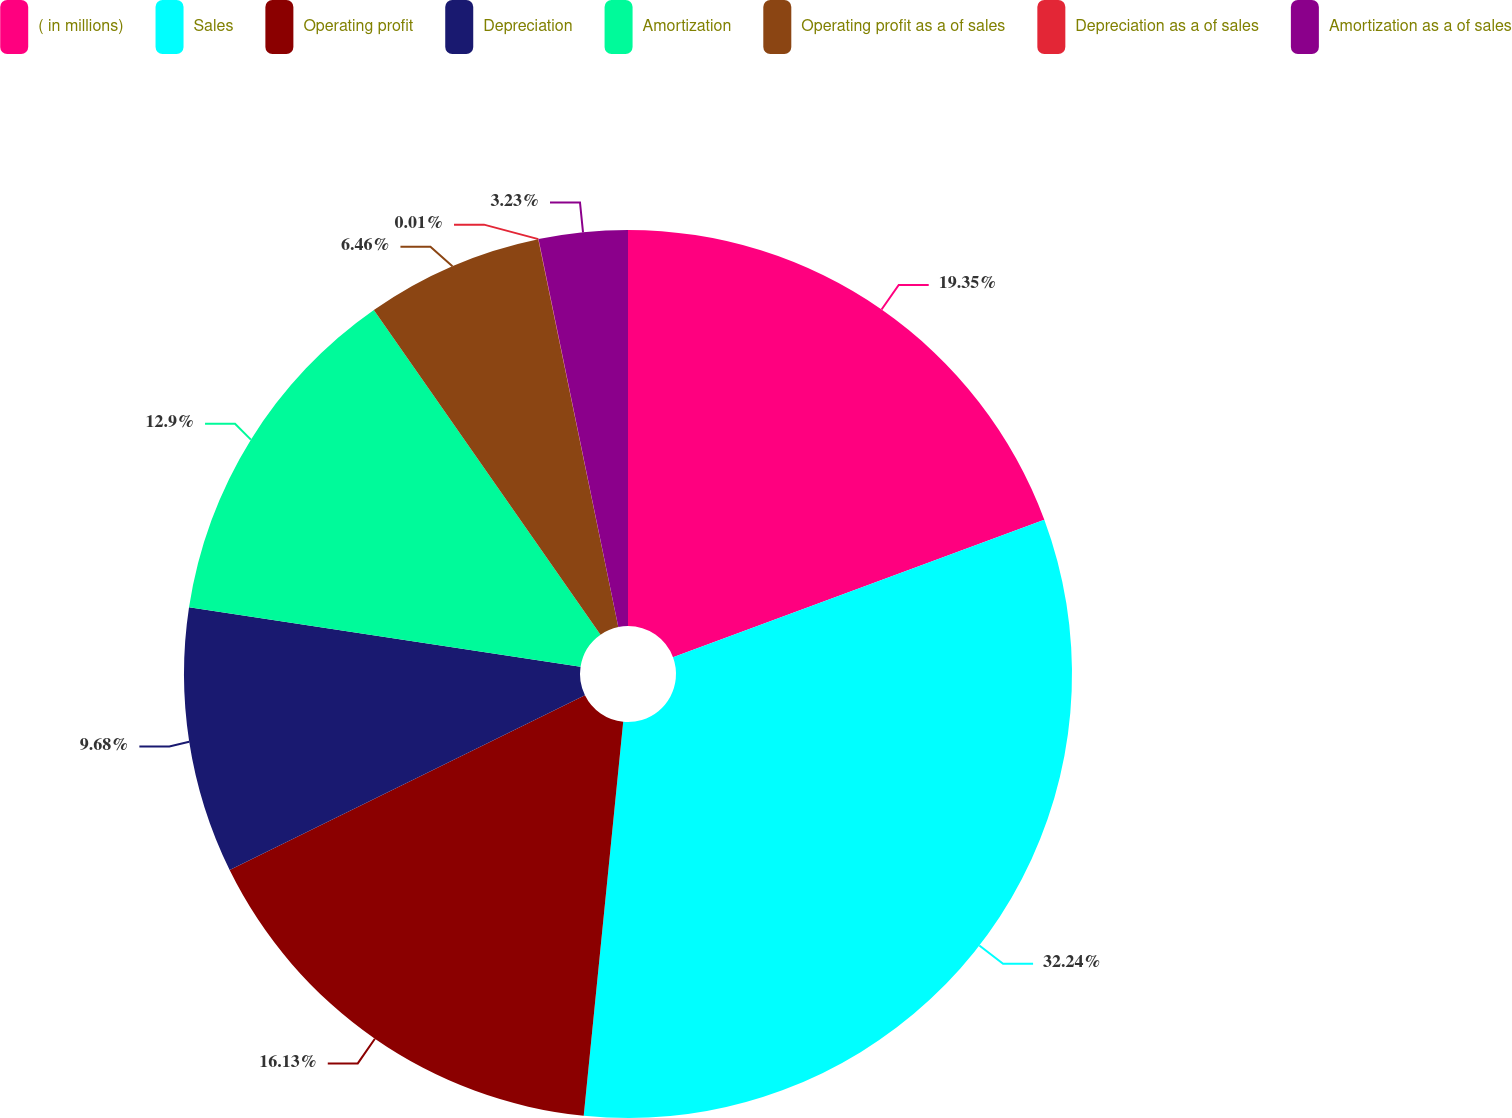Convert chart to OTSL. <chart><loc_0><loc_0><loc_500><loc_500><pie_chart><fcel>( in millions)<fcel>Sales<fcel>Operating profit<fcel>Depreciation<fcel>Amortization<fcel>Operating profit as a of sales<fcel>Depreciation as a of sales<fcel>Amortization as a of sales<nl><fcel>19.35%<fcel>32.24%<fcel>16.13%<fcel>9.68%<fcel>12.9%<fcel>6.46%<fcel>0.01%<fcel>3.23%<nl></chart> 